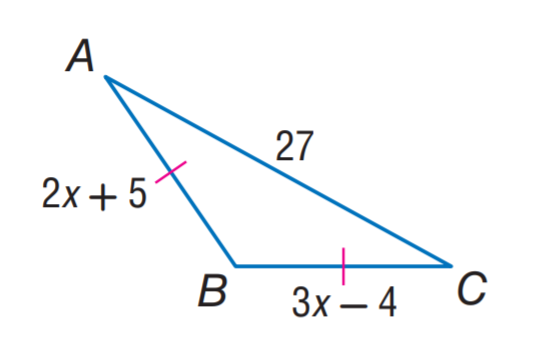Answer the mathemtical geometry problem and directly provide the correct option letter.
Question: Find B C.
Choices: A: 23 B: 24 C: 25 D: 27 A 